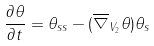<formula> <loc_0><loc_0><loc_500><loc_500>\frac { \partial \theta } { \partial t } = \theta _ { s s } - ( \overline { \nabla } _ { V _ { 2 } } \theta ) \theta _ { s }</formula> 